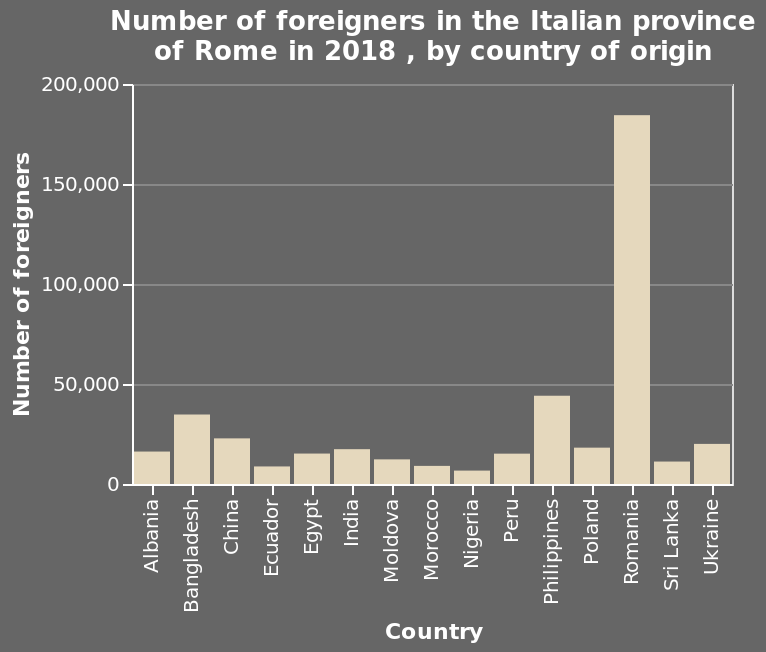<image>
Offer a thorough analysis of the image. The foreigners in the province come from 15 separate countries. The biggest minority comes from Romania and the smallest from Nigeria. Apart from Romania, all other groups of foreigners (14) are below 50k people, but there are nearly 200k Romanian people in the province. From the other countries, the highest number of people come from the Philippines followed by Bangladesh and what appears to be Ukraine. What is the smallest minority group in the province?  The smallest minority group in the province is from Nigeria. 